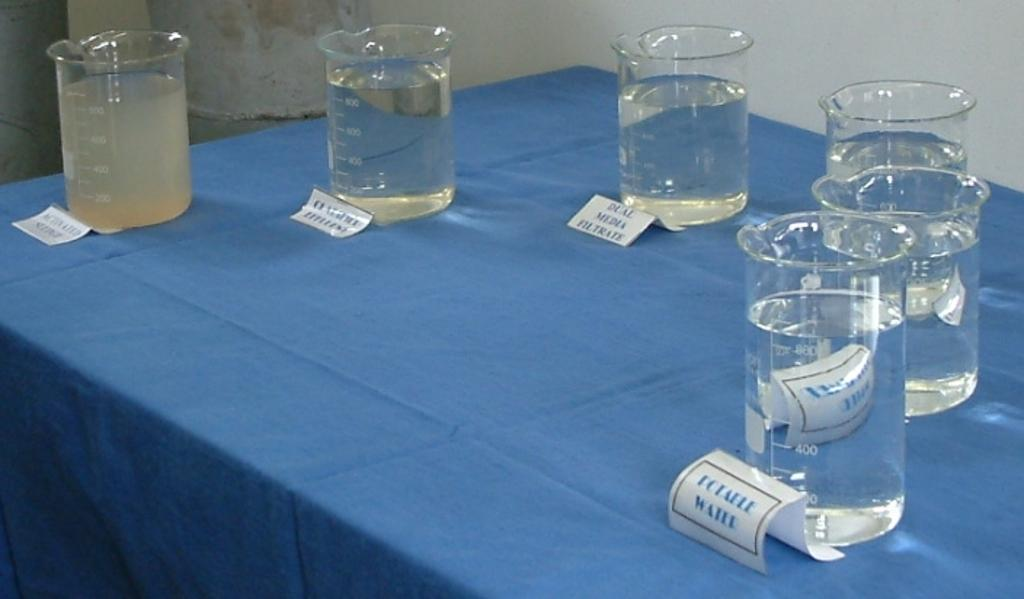Provide a one-sentence caption for the provided image. Cups of liquids placed on a table with one called "Potaele Water". 